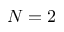<formula> <loc_0><loc_0><loc_500><loc_500>N = 2</formula> 